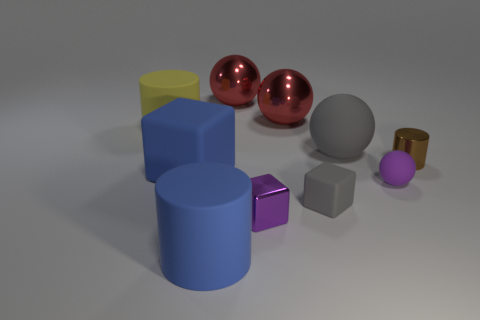How many things are big gray metallic cylinders or big balls on the left side of the small shiny cube?
Your answer should be very brief. 1. Do the large rubber ball and the matte cylinder right of the yellow cylinder have the same color?
Your response must be concise. No. What size is the object that is both right of the big gray sphere and in front of the large matte cube?
Ensure brevity in your answer.  Small. There is a large block; are there any large blue rubber cylinders in front of it?
Ensure brevity in your answer.  Yes. There is a blue matte thing that is right of the blue matte block; is there a gray cube that is in front of it?
Your response must be concise. No. Are there the same number of shiny objects that are left of the purple matte ball and brown shiny cylinders behind the big gray matte ball?
Give a very brief answer. No. There is a block that is the same material as the tiny gray object; what color is it?
Provide a short and direct response. Blue. Are there any large cyan balls made of the same material as the small purple ball?
Your response must be concise. No. How many objects are purple rubber spheres or gray rubber spheres?
Ensure brevity in your answer.  2. Is the material of the small sphere the same as the gray sphere that is on the right side of the big blue matte cylinder?
Your response must be concise. Yes. 